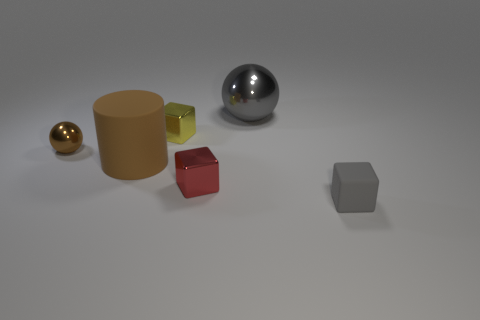What is the atmosphere or mood conveyed by this image? The image gives off a calm and controlled mood, with a subdued color palette and a clean, uncluttered arrangement of objects on a neutral background, evoking a sense of simplicity and order. 